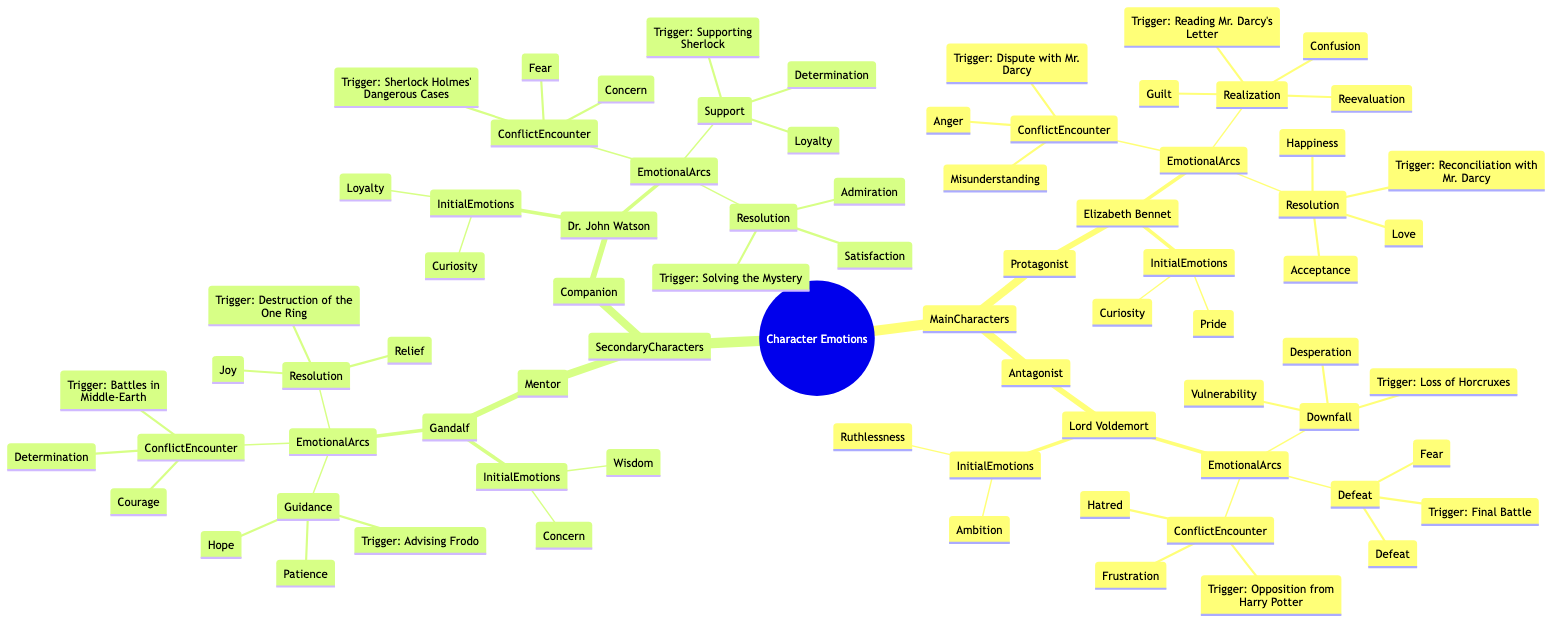What are the initial emotions of Elizabeth Bennet? The node under Elizabeth Bennet lists "Curiosity" and "Pride" as her initial emotions.
Answer: Curiosity, Pride How many emotional arcs does Lord Voldemort have? The diagram shows three emotional arcs listed under Lord Voldemort's section: Conflict Encounter, Downfall, and Defeat.
Answer: 3 What triggers the resolution arc for Gandalf? The resolution arc for Gandalf is triggered by the "Destruction of the One Ring," as seen in the corresponding node.
Answer: Destruction of the One Ring Which character experiences emotions of "Fear" and "Concern" during their conflict encounter? Under Dr. John Watson's emotional arcs, the "ConflictEncounter" section specifies that his emotions during this arc include "Fear" and "Concern."
Answer: Dr. John Watson What is the last emotional arc for Elizabeth Bennet? The last emotional arc mentioned for Elizabeth Bennet in the diagram is "Resolution," which shows her final emotions after reconciling with Mr. Darcy.
Answer: Resolution What primary emotion does Gandalf show initially? The initial emotions for Gandalf include "Wisdom" and "Concern," with "Wisdom" specifically being one of his primary emotions.
Answer: Wisdom How does Elizabeth Bennet feel after her reconciliation with Mr. Darcy? The emotional arc named "Resolution" lists "Acceptance," "Love," and "Happiness" as emotions Elizabeth experiences after reconciling.
Answer: Acceptance, Love, Happiness What is the primary trigger for Lord Voldemort's emotions of "Hatred" and "Frustration"? The "ConflictEncounter" arc under Lord Voldemort specifies that these emotions are triggered by the opposition from Harry Potter.
Answer: Opposition from Harry Potter What emotional state does Gandalf experience after advising Frodo? The emotional arc titled "Guidance" lists "Patience" and "Hope" as the emotions Gandalf experiences after advising Frodo.
Answer: Patience, Hope 